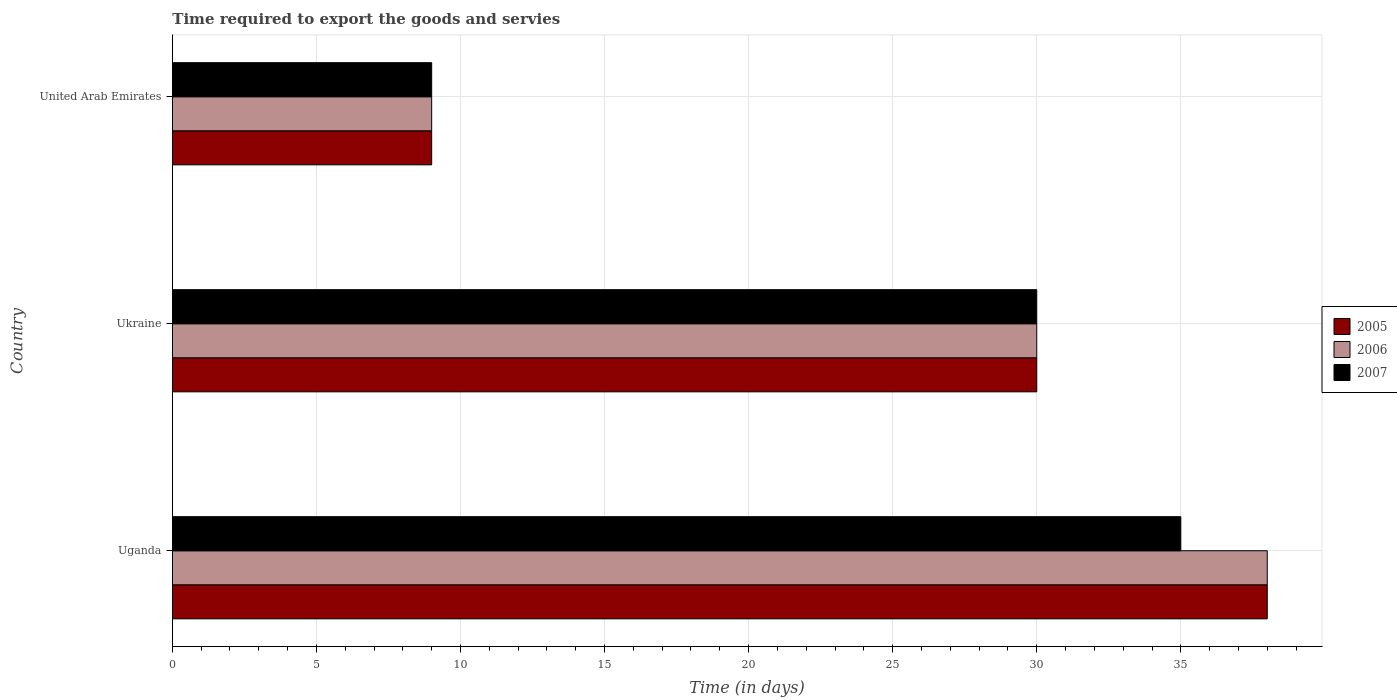How many different coloured bars are there?
Your response must be concise. 3. Are the number of bars per tick equal to the number of legend labels?
Ensure brevity in your answer.  Yes. What is the label of the 2nd group of bars from the top?
Provide a succinct answer. Ukraine. What is the number of days required to export the goods and services in 2007 in United Arab Emirates?
Your answer should be very brief. 9. Across all countries, what is the maximum number of days required to export the goods and services in 2006?
Offer a very short reply. 38. In which country was the number of days required to export the goods and services in 2007 maximum?
Provide a succinct answer. Uganda. In which country was the number of days required to export the goods and services in 2006 minimum?
Provide a succinct answer. United Arab Emirates. What is the difference between the number of days required to export the goods and services in 2005 in Uganda and that in Ukraine?
Your response must be concise. 8. What is the difference between the number of days required to export the goods and services in 2007 in Uganda and the number of days required to export the goods and services in 2005 in Ukraine?
Offer a very short reply. 5. What is the average number of days required to export the goods and services in 2005 per country?
Your answer should be compact. 25.67. What is the difference between the number of days required to export the goods and services in 2007 and number of days required to export the goods and services in 2005 in Ukraine?
Keep it short and to the point. 0. What is the ratio of the number of days required to export the goods and services in 2006 in Uganda to that in United Arab Emirates?
Give a very brief answer. 4.22. Is the number of days required to export the goods and services in 2005 in Uganda less than that in United Arab Emirates?
Give a very brief answer. No. Is the difference between the number of days required to export the goods and services in 2007 in Ukraine and United Arab Emirates greater than the difference between the number of days required to export the goods and services in 2005 in Ukraine and United Arab Emirates?
Ensure brevity in your answer.  No. What is the difference between the highest and the second highest number of days required to export the goods and services in 2006?
Make the answer very short. 8. What is the difference between the highest and the lowest number of days required to export the goods and services in 2007?
Ensure brevity in your answer.  26. What is the difference between two consecutive major ticks on the X-axis?
Give a very brief answer. 5. Are the values on the major ticks of X-axis written in scientific E-notation?
Offer a very short reply. No. Does the graph contain any zero values?
Ensure brevity in your answer.  No. What is the title of the graph?
Keep it short and to the point. Time required to export the goods and servies. What is the label or title of the X-axis?
Your response must be concise. Time (in days). What is the Time (in days) in 2006 in Ukraine?
Keep it short and to the point. 30. What is the Time (in days) in 2007 in United Arab Emirates?
Your answer should be very brief. 9. Across all countries, what is the maximum Time (in days) in 2007?
Your answer should be very brief. 35. Across all countries, what is the minimum Time (in days) of 2007?
Your response must be concise. 9. What is the total Time (in days) in 2005 in the graph?
Your response must be concise. 77. What is the total Time (in days) in 2006 in the graph?
Provide a short and direct response. 77. What is the total Time (in days) of 2007 in the graph?
Provide a succinct answer. 74. What is the difference between the Time (in days) of 2005 in Ukraine and that in United Arab Emirates?
Your response must be concise. 21. What is the difference between the Time (in days) in 2006 in Ukraine and that in United Arab Emirates?
Your response must be concise. 21. What is the difference between the Time (in days) of 2005 in Uganda and the Time (in days) of 2006 in Ukraine?
Offer a very short reply. 8. What is the difference between the Time (in days) in 2005 in Uganda and the Time (in days) in 2006 in United Arab Emirates?
Keep it short and to the point. 29. What is the difference between the Time (in days) in 2005 in Uganda and the Time (in days) in 2007 in United Arab Emirates?
Provide a succinct answer. 29. What is the difference between the Time (in days) of 2005 in Ukraine and the Time (in days) of 2007 in United Arab Emirates?
Offer a very short reply. 21. What is the difference between the Time (in days) of 2006 in Ukraine and the Time (in days) of 2007 in United Arab Emirates?
Provide a short and direct response. 21. What is the average Time (in days) of 2005 per country?
Provide a short and direct response. 25.67. What is the average Time (in days) in 2006 per country?
Ensure brevity in your answer.  25.67. What is the average Time (in days) of 2007 per country?
Provide a succinct answer. 24.67. What is the difference between the Time (in days) in 2005 and Time (in days) in 2007 in Uganda?
Make the answer very short. 3. What is the difference between the Time (in days) in 2006 and Time (in days) in 2007 in Uganda?
Make the answer very short. 3. What is the difference between the Time (in days) of 2005 and Time (in days) of 2006 in Ukraine?
Your answer should be very brief. 0. What is the difference between the Time (in days) of 2005 and Time (in days) of 2007 in Ukraine?
Your response must be concise. 0. What is the difference between the Time (in days) in 2005 and Time (in days) in 2006 in United Arab Emirates?
Your answer should be compact. 0. What is the difference between the Time (in days) of 2006 and Time (in days) of 2007 in United Arab Emirates?
Offer a terse response. 0. What is the ratio of the Time (in days) in 2005 in Uganda to that in Ukraine?
Make the answer very short. 1.27. What is the ratio of the Time (in days) in 2006 in Uganda to that in Ukraine?
Your answer should be compact. 1.27. What is the ratio of the Time (in days) of 2005 in Uganda to that in United Arab Emirates?
Your answer should be compact. 4.22. What is the ratio of the Time (in days) in 2006 in Uganda to that in United Arab Emirates?
Provide a succinct answer. 4.22. What is the ratio of the Time (in days) of 2007 in Uganda to that in United Arab Emirates?
Keep it short and to the point. 3.89. What is the ratio of the Time (in days) in 2007 in Ukraine to that in United Arab Emirates?
Your answer should be very brief. 3.33. What is the difference between the highest and the second highest Time (in days) of 2005?
Offer a terse response. 8. What is the difference between the highest and the lowest Time (in days) in 2005?
Your answer should be compact. 29. 